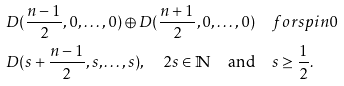<formula> <loc_0><loc_0><loc_500><loc_500>& D ( \frac { n - 1 } { 2 } , 0 , \dots , 0 ) \oplus D ( \frac { n + 1 } { 2 } , 0 , \dots , 0 ) \quad f o r s p i n 0 \\ & D ( s + \frac { n - 1 } { 2 } , s , \dots , s ) , \quad 2 s \in \mathbb { N } \quad \text {and} \quad s \geq \frac { 1 } { 2 } .</formula> 